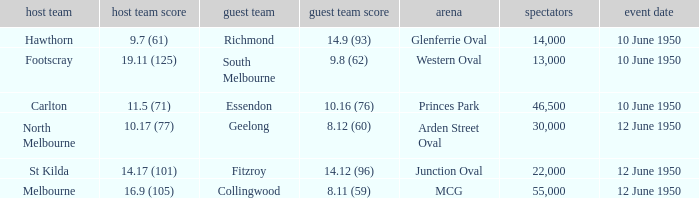What was the crowd when Melbourne was the home team? 55000.0. 